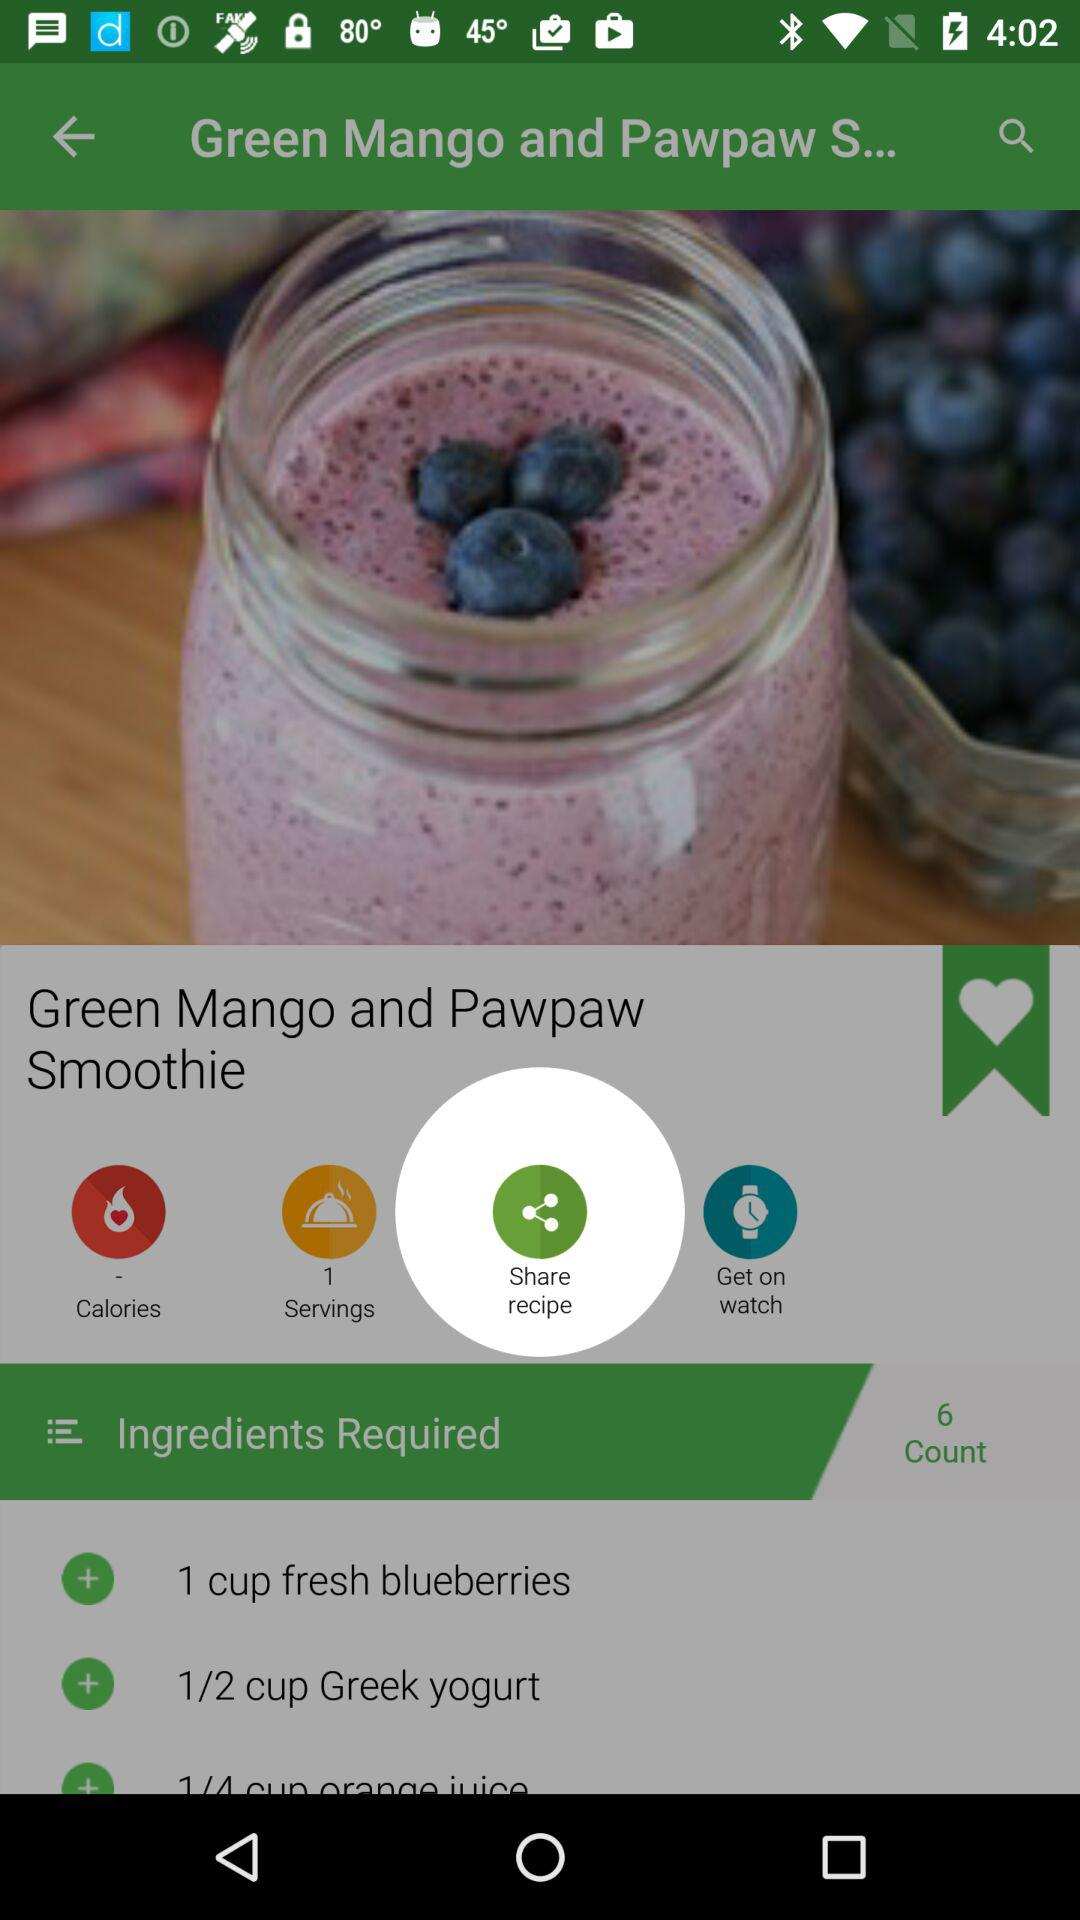What are the required ingredients? The required ingredients are 1 cup fresh blueberries and 1/2 cup Greek yogurt. 